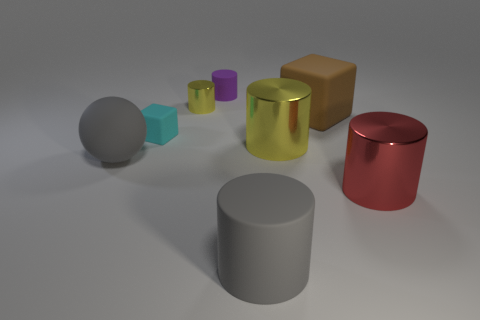How many other things are the same material as the large brown block?
Provide a succinct answer. 4. Are there the same number of red metallic cylinders that are behind the cyan matte block and tiny yellow metallic objects in front of the tiny metallic thing?
Make the answer very short. Yes. What number of yellow objects are small rubber cylinders or small matte cubes?
Give a very brief answer. 0. There is a small matte cylinder; is its color the same as the metal cylinder left of the gray rubber cylinder?
Provide a succinct answer. No. What number of other objects are there of the same color as the big cube?
Keep it short and to the point. 0. Are there fewer small yellow things than gray rubber things?
Your response must be concise. Yes. There is a rubber cylinder that is on the left side of the big object that is in front of the red metal object; how many big brown matte objects are to the right of it?
Provide a succinct answer. 1. How big is the gray ball in front of the brown thing?
Your answer should be very brief. Large. Is the shape of the big gray rubber thing that is right of the tiny rubber cube the same as  the brown object?
Your response must be concise. No. There is a large thing that is the same shape as the tiny cyan matte object; what is its material?
Your answer should be very brief. Rubber. 